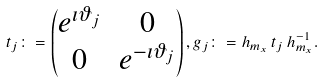Convert formula to latex. <formula><loc_0><loc_0><loc_500><loc_500>t _ { j } \colon = \begin{pmatrix} e ^ { \imath \vartheta _ { j } } & 0 \\ 0 & e ^ { - \imath \vartheta _ { j } } \end{pmatrix} , g _ { j } \colon = h _ { m _ { x } } \, t _ { j } \, h _ { m _ { x } } ^ { - 1 } .</formula> 